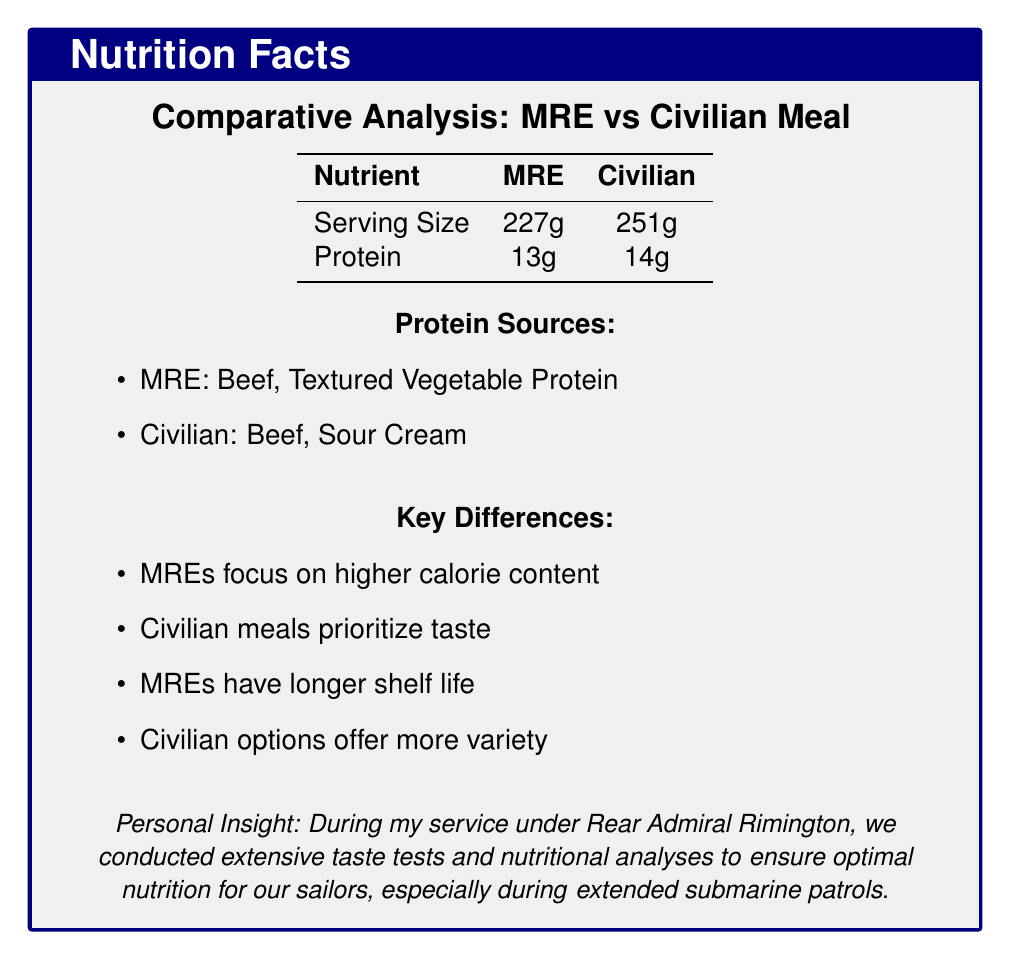what is the serving size of the MRE? The serving size of the MRE is explicitly listed in the tabulated information under the "Serving Size" column for MRE.
Answer: 227g what protein sources are included in the civilian meals? The civilian meals' protein sources are listed under the "Protein Sources" section of the document, specifically showing "Beef" and "Sour Cream".
Answer: Beef, Sour Cream how much protein is in an MRE before and after the average calculation? The MRE protein content is listed as 13g in the visual elements and 13.33g in the comparative analysis section for the average across multiple MREs.
Answer: 13g, 13.33g which type of meal has a higher focus on taste? The document explicitly mentions in the "Key Differences" section that civilian meals prioritize taste over calorie density.
Answer: Civilian meals what are the key differences between MRE and civilian meals? The key differences are summarized in the document under the "Key Differences" section.
Answer: Higher calorie content for MREs, longer shelf life for MREs, more variety in flavors for civilian options which of the following protein sources is not mentioned in the MRE section? A. Beef B. Chicken C. Tofu The MRE section lists Beef, Textured Vegetable Protein, Chicken, Egg Noodles, and Pork, but does not mention Tofu.
Answer: C. Tofu which meal is used by hikers and campers? A. Mountain House Beef Stroganoff B. Backpacker's Pantry Pad Thai C. ReadyWise Emergency Food Supply Teriyaki Rice The civilian section lists the "Mountain House Beef Stroganoff" as a popular choice among hikers and campers.
Answer: A. Mountain House Beef Stroganoff are MREs more focused on higher calorie content? The document states that MREs focus on higher calorie content, as noted in the "Key Differences" section.
Answer: Yes summarize the main idea of the document. The document compares military and civilian meals, detailing protein content, differences in focus like energy content and taste, and providing personal insights from service under Rear Admiral Rimington.
Answer: The document provides a comparative analysis of protein sources in military MREs and civilian ready-to-eat meals, highlighting their nutritional content, key differences, and insights from personal experience. what are the protein sources in the Pork Sausage Patty MRE? The protein source for the Pork Sausage Patty MRE is listed as "Pork" in the section describing different MRE protein sources.
Answer: Pork how does the average protein content of MREs compare to civilian meals? The comparative analysis section states the average protein content is 13.33g for MREs and 13.67g for civilian meals, showing a slight edge for civilian options.
Answer: Civilian meals have a slightly higher average protein content. what specific group is mentioned for the use of Chicken, Egg Noodles, and Vegetables MRE? The military relevance of the Chicken, Egg Noodles, and Vegetables MRE is described as providing balanced nutrition for submarine crews.
Answer: Submarine crews who conducted taste tests and nutritional analyses to ensure optimal nutrition? The document includes a personal insight that states these tests were conducted during service under Rear Admiral Rimington.
Answer: Navy personnel under Rear Admiral Rimington what protein sources are used in ready-to-eat meals focused on vegetarian options? The "Backpacker's Pantry Pad Thai" is a vegetarian option that lists Tofu and Peanuts as protein sources.
Answer: Tofu, Peanuts are there allergen-free options mentioned for military rations? The document mentions that civilian meals offer more allergen-free options but does not specify whether military rations provide allergen-free options.
Answer: Not enough information 